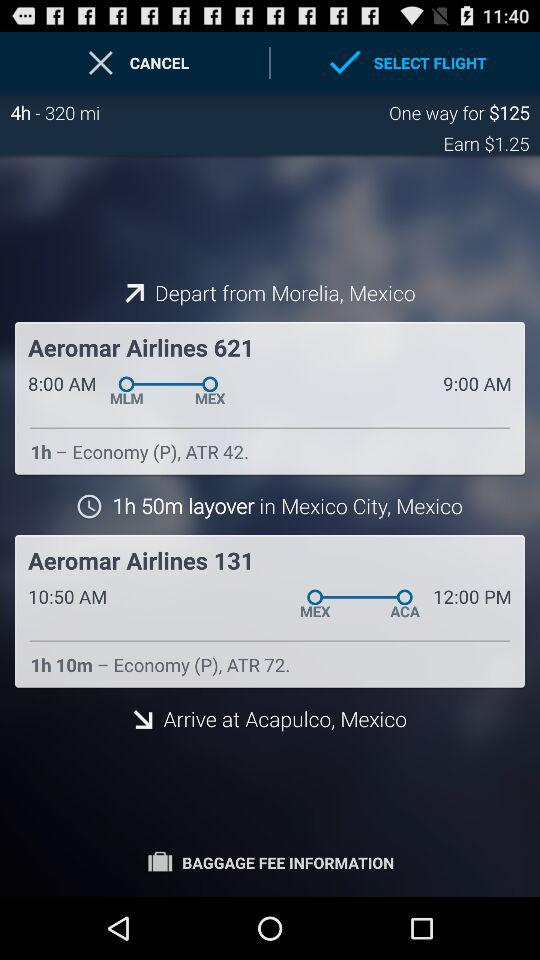What is the departure station? The departure station is Morelia, Mexico. 